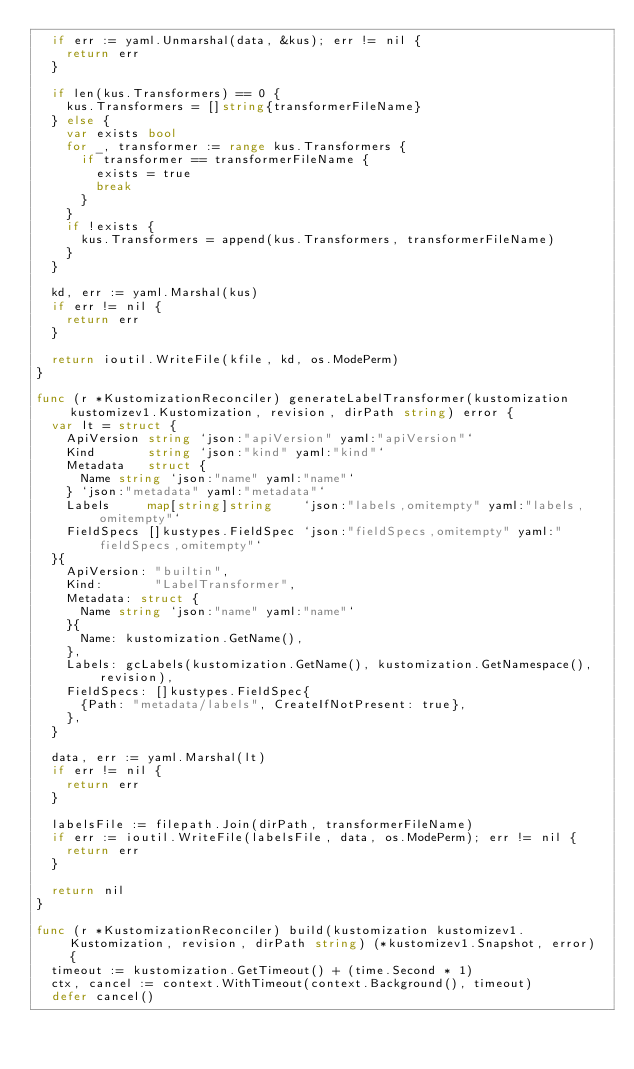<code> <loc_0><loc_0><loc_500><loc_500><_Go_>	if err := yaml.Unmarshal(data, &kus); err != nil {
		return err
	}

	if len(kus.Transformers) == 0 {
		kus.Transformers = []string{transformerFileName}
	} else {
		var exists bool
		for _, transformer := range kus.Transformers {
			if transformer == transformerFileName {
				exists = true
				break
			}
		}
		if !exists {
			kus.Transformers = append(kus.Transformers, transformerFileName)
		}
	}

	kd, err := yaml.Marshal(kus)
	if err != nil {
		return err
	}

	return ioutil.WriteFile(kfile, kd, os.ModePerm)
}

func (r *KustomizationReconciler) generateLabelTransformer(kustomization kustomizev1.Kustomization, revision, dirPath string) error {
	var lt = struct {
		ApiVersion string `json:"apiVersion" yaml:"apiVersion"`
		Kind       string `json:"kind" yaml:"kind"`
		Metadata   struct {
			Name string `json:"name" yaml:"name"`
		} `json:"metadata" yaml:"metadata"`
		Labels     map[string]string    `json:"labels,omitempty" yaml:"labels,omitempty"`
		FieldSpecs []kustypes.FieldSpec `json:"fieldSpecs,omitempty" yaml:"fieldSpecs,omitempty"`
	}{
		ApiVersion: "builtin",
		Kind:       "LabelTransformer",
		Metadata: struct {
			Name string `json:"name" yaml:"name"`
		}{
			Name: kustomization.GetName(),
		},
		Labels: gcLabels(kustomization.GetName(), kustomization.GetNamespace(), revision),
		FieldSpecs: []kustypes.FieldSpec{
			{Path: "metadata/labels", CreateIfNotPresent: true},
		},
	}

	data, err := yaml.Marshal(lt)
	if err != nil {
		return err
	}

	labelsFile := filepath.Join(dirPath, transformerFileName)
	if err := ioutil.WriteFile(labelsFile, data, os.ModePerm); err != nil {
		return err
	}

	return nil
}

func (r *KustomizationReconciler) build(kustomization kustomizev1.Kustomization, revision, dirPath string) (*kustomizev1.Snapshot, error) {
	timeout := kustomization.GetTimeout() + (time.Second * 1)
	ctx, cancel := context.WithTimeout(context.Background(), timeout)
	defer cancel()
</code> 